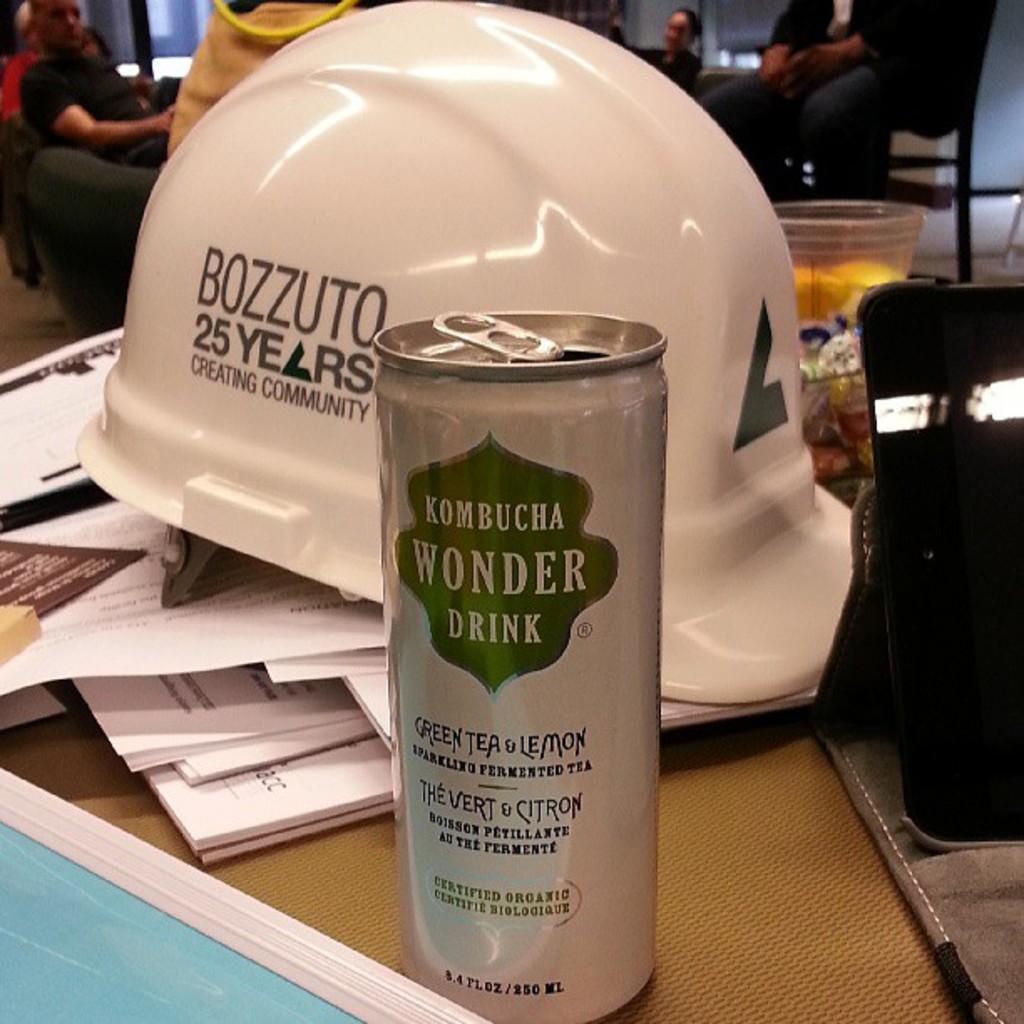Could you give a brief overview of what you see in this image? In this image, we can see persons wearing clothes. There is a helmet on papers. There is a tin at the bottom of the image. There is a tablet on the right side of the image. 